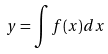Convert formula to latex. <formula><loc_0><loc_0><loc_500><loc_500>y = \int f ( x ) d x</formula> 